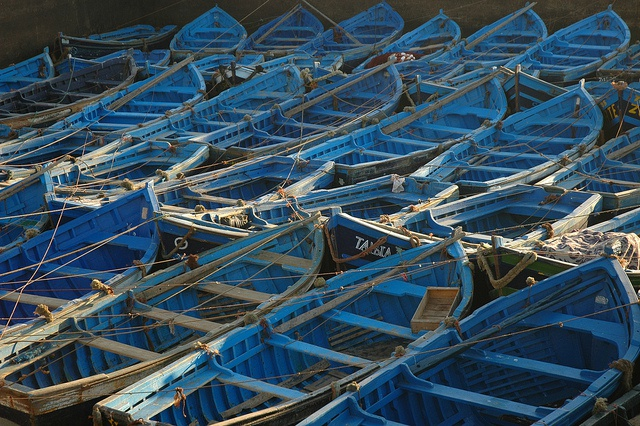Describe the objects in this image and their specific colors. I can see boat in black, blue, navy, and gray tones, boat in black, navy, and blue tones, boat in black, navy, teal, and gray tones, boat in black, gray, blue, and darkblue tones, and boat in black, navy, blue, and gray tones in this image. 